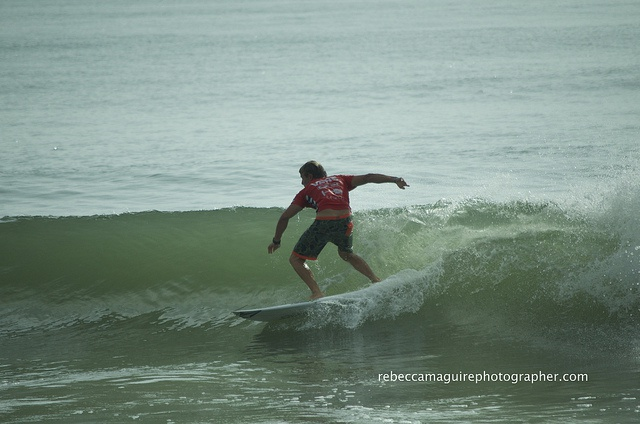Describe the objects in this image and their specific colors. I can see people in gray, black, and maroon tones and surfboard in gray, darkgray, and black tones in this image. 